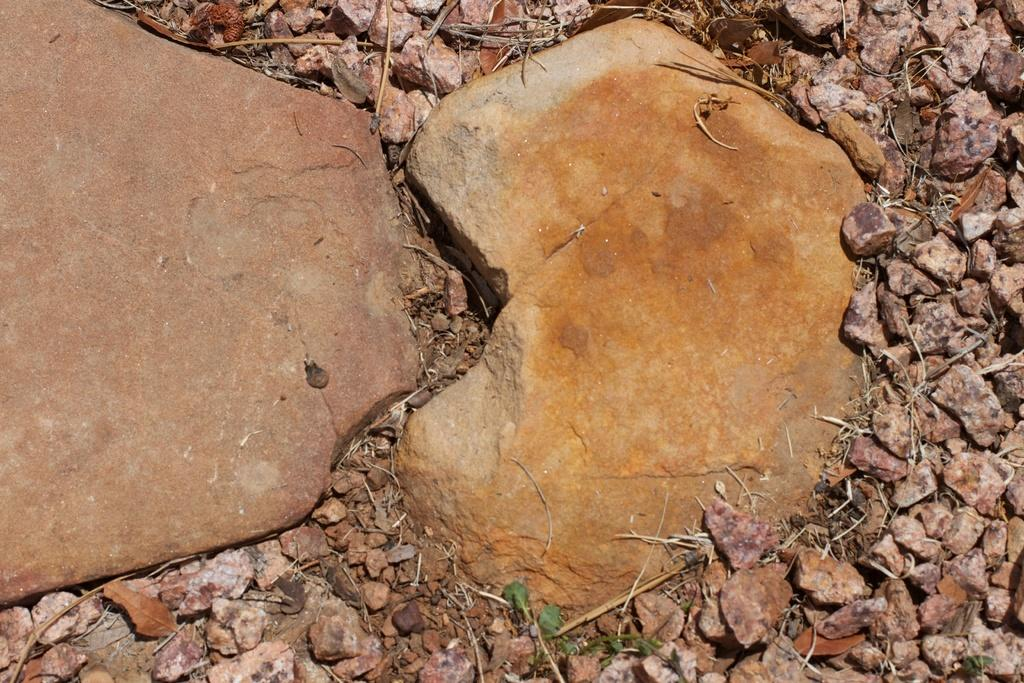What type of objects can be seen on the ground in the image? There are two big stones and a few small stones in the image. Can you describe the size of the stones in the image? The stones in the image can be categorized into two sizes: two big stones and a few small stones. Where are the stones located in the image? The stones are on the ground in the image. What type of trains can be seen passing by the stones in the image? There are no trains present in the image; it only features stones on the ground. 